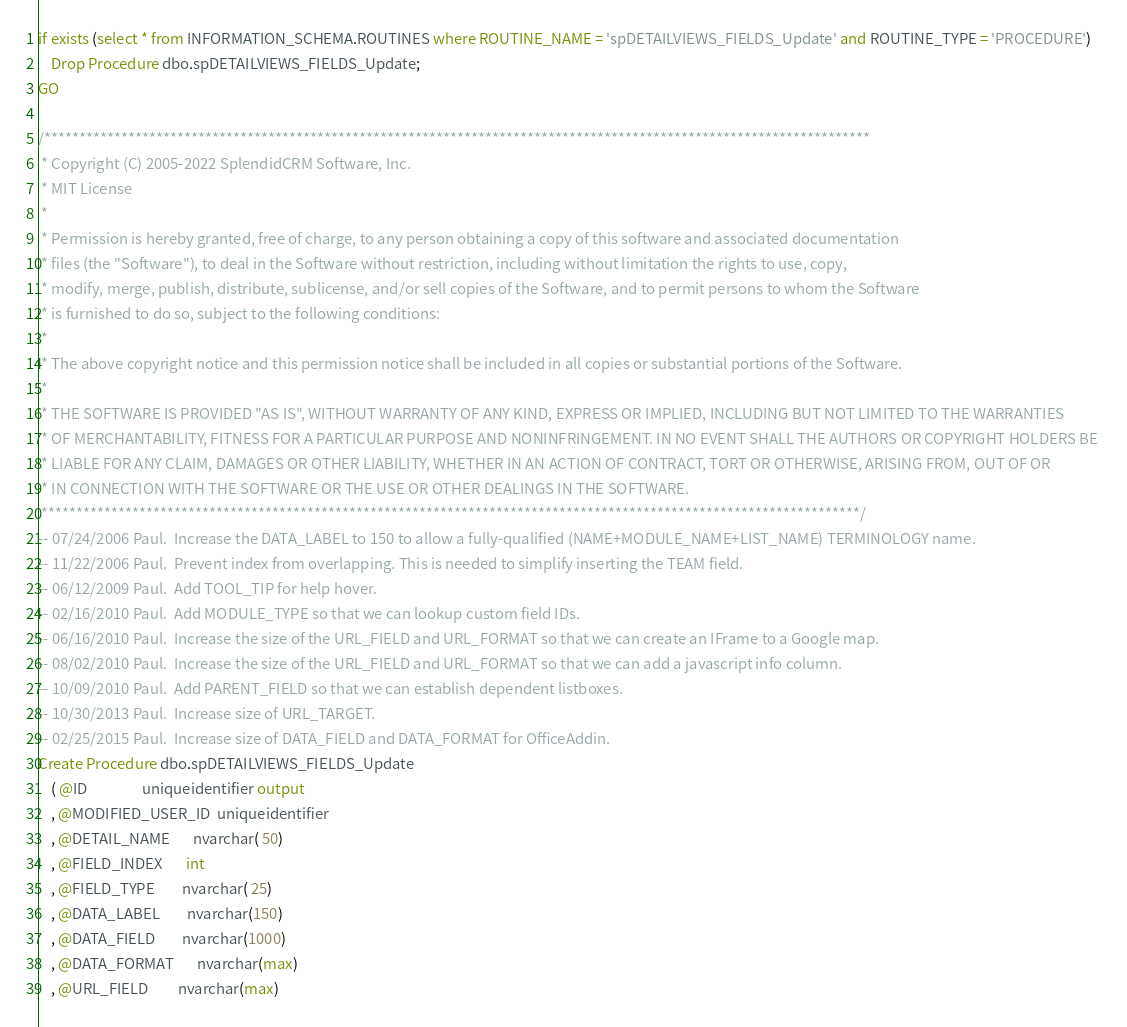<code> <loc_0><loc_0><loc_500><loc_500><_SQL_>if exists (select * from INFORMATION_SCHEMA.ROUTINES where ROUTINE_NAME = 'spDETAILVIEWS_FIELDS_Update' and ROUTINE_TYPE = 'PROCEDURE')
	Drop Procedure dbo.spDETAILVIEWS_FIELDS_Update;
GO
 
/**********************************************************************************************************************
 * Copyright (C) 2005-2022 SplendidCRM Software, Inc. 
 * MIT License
 * 
 * Permission is hereby granted, free of charge, to any person obtaining a copy of this software and associated documentation 
 * files (the "Software"), to deal in the Software without restriction, including without limitation the rights to use, copy, 
 * modify, merge, publish, distribute, sublicense, and/or sell copies of the Software, and to permit persons to whom the Software 
 * is furnished to do so, subject to the following conditions:
 * 
 * The above copyright notice and this permission notice shall be included in all copies or substantial portions of the Software.
 * 
 * THE SOFTWARE IS PROVIDED "AS IS", WITHOUT WARRANTY OF ANY KIND, EXPRESS OR IMPLIED, INCLUDING BUT NOT LIMITED TO THE WARRANTIES 
 * OF MERCHANTABILITY, FITNESS FOR A PARTICULAR PURPOSE AND NONINFRINGEMENT. IN NO EVENT SHALL THE AUTHORS OR COPYRIGHT HOLDERS BE 
 * LIABLE FOR ANY CLAIM, DAMAGES OR OTHER LIABILITY, WHETHER IN AN ACTION OF CONTRACT, TORT OR OTHERWISE, ARISING FROM, OUT OF OR 
 * IN CONNECTION WITH THE SOFTWARE OR THE USE OR OTHER DEALINGS IN THE SOFTWARE.
 *********************************************************************************************************************/
-- 07/24/2006 Paul.  Increase the DATA_LABEL to 150 to allow a fully-qualified (NAME+MODULE_NAME+LIST_NAME) TERMINOLOGY name. 
-- 11/22/2006 Paul.  Prevent index from overlapping. This is needed to simplify inserting the TEAM field. 
-- 06/12/2009 Paul.  Add TOOL_TIP for help hover.
-- 02/16/2010 Paul.  Add MODULE_TYPE so that we can lookup custom field IDs. 
-- 06/16/2010 Paul.  Increase the size of the URL_FIELD and URL_FORMAT so that we can create an IFrame to a Google map. 
-- 08/02/2010 Paul.  Increase the size of the URL_FIELD and URL_FORMAT so that we can add a javascript info column. 
-- 10/09/2010 Paul.  Add PARENT_FIELD so that we can establish dependent listboxes. 
-- 10/30/2013 Paul.  Increase size of URL_TARGET. 
-- 02/25/2015 Paul.  Increase size of DATA_FIELD and DATA_FORMAT for OfficeAddin. 
Create Procedure dbo.spDETAILVIEWS_FIELDS_Update
	( @ID                uniqueidentifier output
	, @MODIFIED_USER_ID  uniqueidentifier
	, @DETAIL_NAME       nvarchar( 50)
	, @FIELD_INDEX       int
	, @FIELD_TYPE        nvarchar( 25)
	, @DATA_LABEL        nvarchar(150)
	, @DATA_FIELD        nvarchar(1000)
	, @DATA_FORMAT       nvarchar(max)
	, @URL_FIELD         nvarchar(max)</code> 